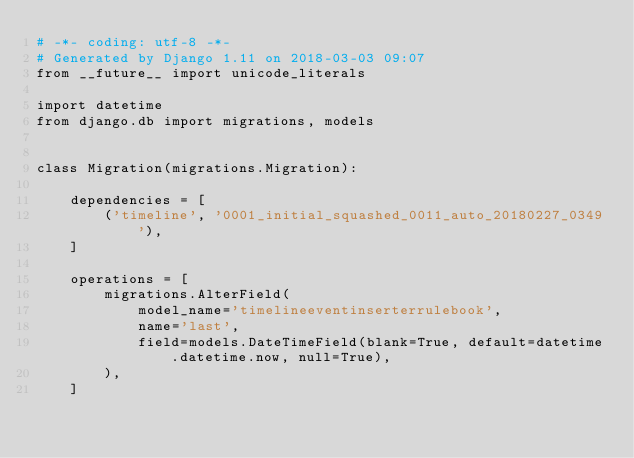<code> <loc_0><loc_0><loc_500><loc_500><_Python_># -*- coding: utf-8 -*-
# Generated by Django 1.11 on 2018-03-03 09:07
from __future__ import unicode_literals

import datetime
from django.db import migrations, models


class Migration(migrations.Migration):

    dependencies = [
        ('timeline', '0001_initial_squashed_0011_auto_20180227_0349'),
    ]

    operations = [
        migrations.AlterField(
            model_name='timelineeventinserterrulebook',
            name='last',
            field=models.DateTimeField(blank=True, default=datetime.datetime.now, null=True),
        ),
    ]
</code> 